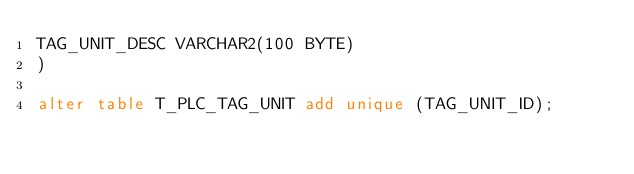Convert code to text. <code><loc_0><loc_0><loc_500><loc_500><_SQL_>TAG_UNIT_DESC VARCHAR2(100 BYTE)
)

alter table T_PLC_TAG_UNIT add unique (TAG_UNIT_ID);</code> 